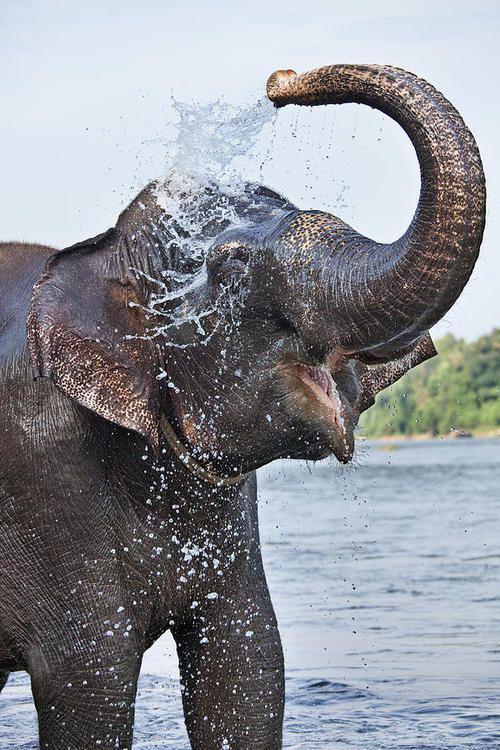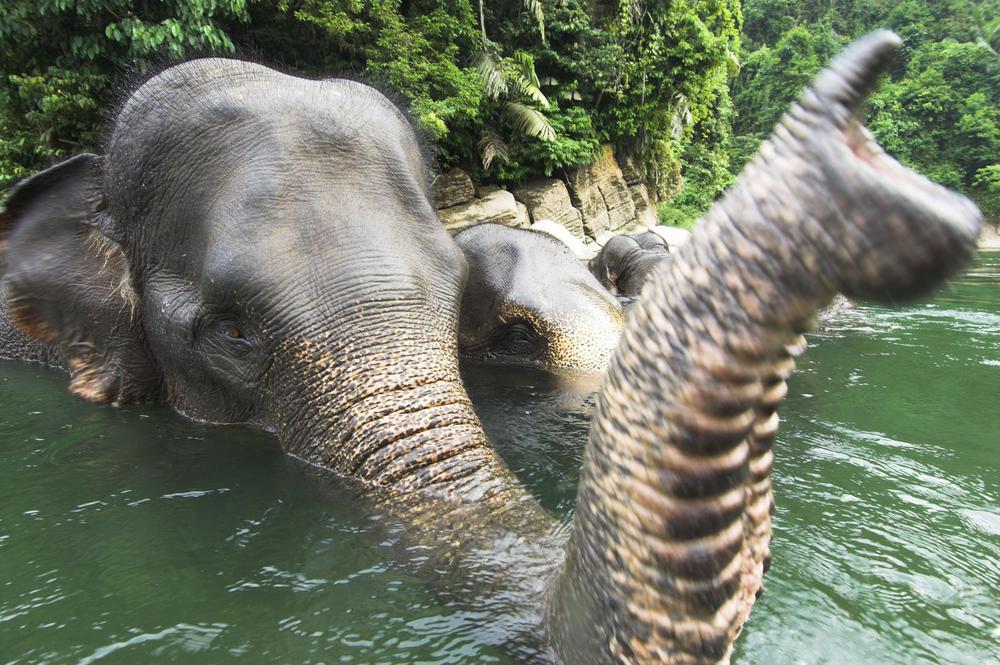The first image is the image on the left, the second image is the image on the right. Given the left and right images, does the statement "One of the images contains exactly four elephants." hold true? Answer yes or no. No. The first image is the image on the left, the second image is the image on the right. For the images shown, is this caption "There are at least four elephants in the water." true? Answer yes or no. No. 